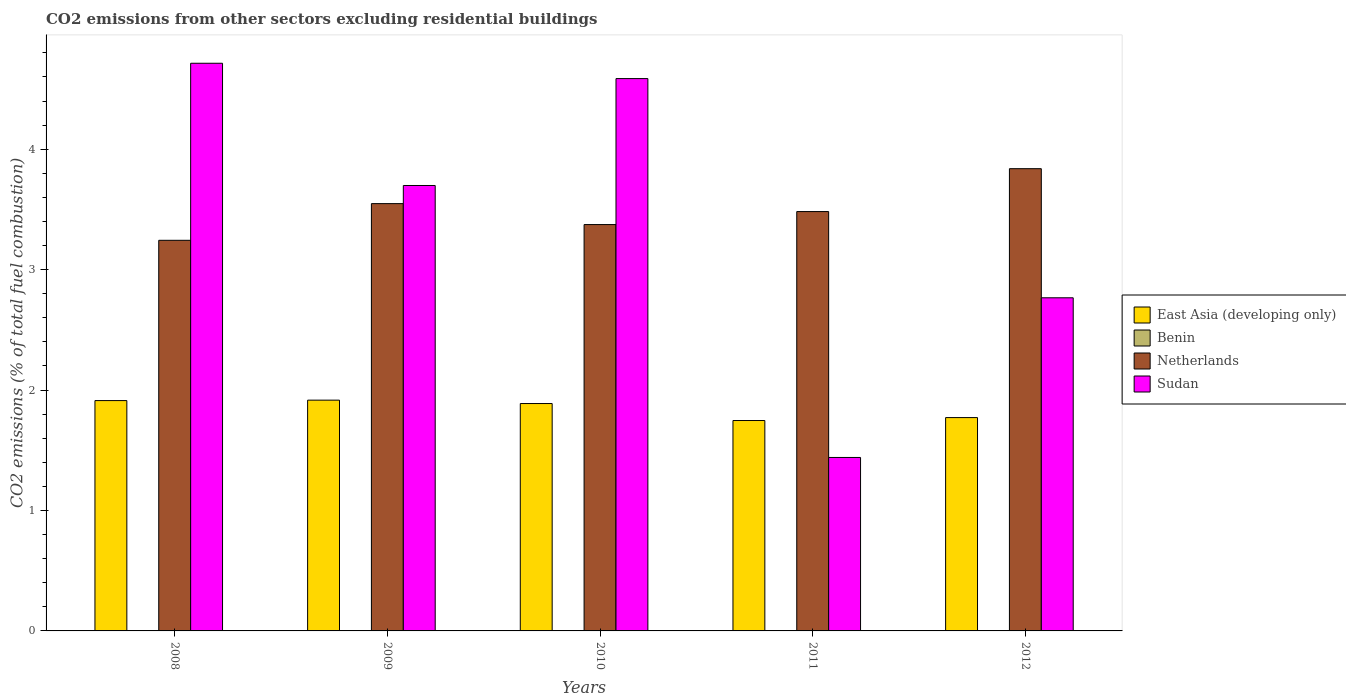How many groups of bars are there?
Offer a very short reply. 5. Are the number of bars per tick equal to the number of legend labels?
Your answer should be very brief. No. How many bars are there on the 5th tick from the left?
Your answer should be compact. 4. How many bars are there on the 4th tick from the right?
Your answer should be compact. 3. What is the total CO2 emitted in East Asia (developing only) in 2009?
Give a very brief answer. 1.92. Across all years, what is the maximum total CO2 emitted in Sudan?
Offer a terse response. 4.71. Across all years, what is the minimum total CO2 emitted in Benin?
Your answer should be very brief. 0. In which year was the total CO2 emitted in Benin maximum?
Provide a succinct answer. 2008. What is the total total CO2 emitted in Benin in the graph?
Provide a succinct answer. 7.807697859994709e-16. What is the difference between the total CO2 emitted in East Asia (developing only) in 2008 and that in 2012?
Make the answer very short. 0.14. What is the difference between the total CO2 emitted in Sudan in 2011 and the total CO2 emitted in East Asia (developing only) in 2009?
Provide a short and direct response. -0.48. What is the average total CO2 emitted in Sudan per year?
Provide a succinct answer. 3.44. In the year 2009, what is the difference between the total CO2 emitted in Sudan and total CO2 emitted in Netherlands?
Provide a short and direct response. 0.15. In how many years, is the total CO2 emitted in Netherlands greater than 1.4?
Provide a succinct answer. 5. What is the ratio of the total CO2 emitted in East Asia (developing only) in 2008 to that in 2011?
Offer a very short reply. 1.09. What is the difference between the highest and the second highest total CO2 emitted in Sudan?
Ensure brevity in your answer.  0.13. What is the difference between the highest and the lowest total CO2 emitted in Benin?
Your answer should be compact. 2.282530889443169e-16. In how many years, is the total CO2 emitted in Benin greater than the average total CO2 emitted in Benin taken over all years?
Offer a terse response. 4. Is the sum of the total CO2 emitted in Benin in 2010 and 2011 greater than the maximum total CO2 emitted in East Asia (developing only) across all years?
Offer a very short reply. No. How many bars are there?
Give a very brief answer. 19. Are all the bars in the graph horizontal?
Your answer should be very brief. No. What is the difference between two consecutive major ticks on the Y-axis?
Make the answer very short. 1. Does the graph contain grids?
Keep it short and to the point. No. How many legend labels are there?
Provide a succinct answer. 4. What is the title of the graph?
Provide a succinct answer. CO2 emissions from other sectors excluding residential buildings. What is the label or title of the Y-axis?
Keep it short and to the point. CO2 emissions (% of total fuel combustion). What is the CO2 emissions (% of total fuel combustion) in East Asia (developing only) in 2008?
Provide a short and direct response. 1.91. What is the CO2 emissions (% of total fuel combustion) in Benin in 2008?
Ensure brevity in your answer.  2.282530889443169e-16. What is the CO2 emissions (% of total fuel combustion) in Netherlands in 2008?
Ensure brevity in your answer.  3.24. What is the CO2 emissions (% of total fuel combustion) of Sudan in 2008?
Provide a short and direct response. 4.71. What is the CO2 emissions (% of total fuel combustion) in East Asia (developing only) in 2009?
Make the answer very short. 1.92. What is the CO2 emissions (% of total fuel combustion) of Benin in 2009?
Keep it short and to the point. 0. What is the CO2 emissions (% of total fuel combustion) in Netherlands in 2009?
Your answer should be compact. 3.55. What is the CO2 emissions (% of total fuel combustion) in Sudan in 2009?
Your answer should be very brief. 3.7. What is the CO2 emissions (% of total fuel combustion) in East Asia (developing only) in 2010?
Provide a succinct answer. 1.89. What is the CO2 emissions (% of total fuel combustion) of Benin in 2010?
Keep it short and to the point. 1.92747052886312e-16. What is the CO2 emissions (% of total fuel combustion) of Netherlands in 2010?
Provide a short and direct response. 3.37. What is the CO2 emissions (% of total fuel combustion) of Sudan in 2010?
Offer a very short reply. 4.59. What is the CO2 emissions (% of total fuel combustion) in East Asia (developing only) in 2011?
Offer a terse response. 1.75. What is the CO2 emissions (% of total fuel combustion) of Benin in 2011?
Provide a short and direct response. 1.84545050635831e-16. What is the CO2 emissions (% of total fuel combustion) of Netherlands in 2011?
Offer a terse response. 3.48. What is the CO2 emissions (% of total fuel combustion) in Sudan in 2011?
Give a very brief answer. 1.44. What is the CO2 emissions (% of total fuel combustion) of East Asia (developing only) in 2012?
Your response must be concise. 1.77. What is the CO2 emissions (% of total fuel combustion) of Benin in 2012?
Give a very brief answer. 1.75224593533011e-16. What is the CO2 emissions (% of total fuel combustion) of Netherlands in 2012?
Provide a succinct answer. 3.84. What is the CO2 emissions (% of total fuel combustion) of Sudan in 2012?
Make the answer very short. 2.77. Across all years, what is the maximum CO2 emissions (% of total fuel combustion) in East Asia (developing only)?
Keep it short and to the point. 1.92. Across all years, what is the maximum CO2 emissions (% of total fuel combustion) of Benin?
Your response must be concise. 2.282530889443169e-16. Across all years, what is the maximum CO2 emissions (% of total fuel combustion) in Netherlands?
Ensure brevity in your answer.  3.84. Across all years, what is the maximum CO2 emissions (% of total fuel combustion) of Sudan?
Your answer should be very brief. 4.71. Across all years, what is the minimum CO2 emissions (% of total fuel combustion) in East Asia (developing only)?
Provide a succinct answer. 1.75. Across all years, what is the minimum CO2 emissions (% of total fuel combustion) in Benin?
Offer a very short reply. 0. Across all years, what is the minimum CO2 emissions (% of total fuel combustion) of Netherlands?
Offer a terse response. 3.24. Across all years, what is the minimum CO2 emissions (% of total fuel combustion) of Sudan?
Keep it short and to the point. 1.44. What is the total CO2 emissions (% of total fuel combustion) in East Asia (developing only) in the graph?
Your answer should be compact. 9.24. What is the total CO2 emissions (% of total fuel combustion) of Benin in the graph?
Provide a succinct answer. 0. What is the total CO2 emissions (% of total fuel combustion) of Netherlands in the graph?
Ensure brevity in your answer.  17.49. What is the total CO2 emissions (% of total fuel combustion) in Sudan in the graph?
Keep it short and to the point. 17.21. What is the difference between the CO2 emissions (% of total fuel combustion) of East Asia (developing only) in 2008 and that in 2009?
Ensure brevity in your answer.  -0. What is the difference between the CO2 emissions (% of total fuel combustion) in Netherlands in 2008 and that in 2009?
Give a very brief answer. -0.3. What is the difference between the CO2 emissions (% of total fuel combustion) in Sudan in 2008 and that in 2009?
Offer a terse response. 1.01. What is the difference between the CO2 emissions (% of total fuel combustion) in East Asia (developing only) in 2008 and that in 2010?
Ensure brevity in your answer.  0.02. What is the difference between the CO2 emissions (% of total fuel combustion) of Benin in 2008 and that in 2010?
Offer a terse response. 0. What is the difference between the CO2 emissions (% of total fuel combustion) in Netherlands in 2008 and that in 2010?
Offer a terse response. -0.13. What is the difference between the CO2 emissions (% of total fuel combustion) of Sudan in 2008 and that in 2010?
Ensure brevity in your answer.  0.13. What is the difference between the CO2 emissions (% of total fuel combustion) in East Asia (developing only) in 2008 and that in 2011?
Your answer should be very brief. 0.17. What is the difference between the CO2 emissions (% of total fuel combustion) of Benin in 2008 and that in 2011?
Ensure brevity in your answer.  0. What is the difference between the CO2 emissions (% of total fuel combustion) in Netherlands in 2008 and that in 2011?
Your answer should be very brief. -0.24. What is the difference between the CO2 emissions (% of total fuel combustion) in Sudan in 2008 and that in 2011?
Keep it short and to the point. 3.27. What is the difference between the CO2 emissions (% of total fuel combustion) in East Asia (developing only) in 2008 and that in 2012?
Make the answer very short. 0.14. What is the difference between the CO2 emissions (% of total fuel combustion) of Benin in 2008 and that in 2012?
Offer a terse response. 0. What is the difference between the CO2 emissions (% of total fuel combustion) of Netherlands in 2008 and that in 2012?
Offer a terse response. -0.59. What is the difference between the CO2 emissions (% of total fuel combustion) of Sudan in 2008 and that in 2012?
Keep it short and to the point. 1.95. What is the difference between the CO2 emissions (% of total fuel combustion) in East Asia (developing only) in 2009 and that in 2010?
Your answer should be compact. 0.03. What is the difference between the CO2 emissions (% of total fuel combustion) of Netherlands in 2009 and that in 2010?
Provide a succinct answer. 0.17. What is the difference between the CO2 emissions (% of total fuel combustion) in Sudan in 2009 and that in 2010?
Make the answer very short. -0.89. What is the difference between the CO2 emissions (% of total fuel combustion) in East Asia (developing only) in 2009 and that in 2011?
Ensure brevity in your answer.  0.17. What is the difference between the CO2 emissions (% of total fuel combustion) of Netherlands in 2009 and that in 2011?
Offer a terse response. 0.07. What is the difference between the CO2 emissions (% of total fuel combustion) of Sudan in 2009 and that in 2011?
Your answer should be very brief. 2.26. What is the difference between the CO2 emissions (% of total fuel combustion) in East Asia (developing only) in 2009 and that in 2012?
Your response must be concise. 0.14. What is the difference between the CO2 emissions (% of total fuel combustion) of Netherlands in 2009 and that in 2012?
Your answer should be compact. -0.29. What is the difference between the CO2 emissions (% of total fuel combustion) of Sudan in 2009 and that in 2012?
Offer a very short reply. 0.93. What is the difference between the CO2 emissions (% of total fuel combustion) of East Asia (developing only) in 2010 and that in 2011?
Provide a succinct answer. 0.14. What is the difference between the CO2 emissions (% of total fuel combustion) in Netherlands in 2010 and that in 2011?
Your answer should be very brief. -0.11. What is the difference between the CO2 emissions (% of total fuel combustion) in Sudan in 2010 and that in 2011?
Provide a succinct answer. 3.15. What is the difference between the CO2 emissions (% of total fuel combustion) of East Asia (developing only) in 2010 and that in 2012?
Make the answer very short. 0.12. What is the difference between the CO2 emissions (% of total fuel combustion) of Netherlands in 2010 and that in 2012?
Ensure brevity in your answer.  -0.46. What is the difference between the CO2 emissions (% of total fuel combustion) in Sudan in 2010 and that in 2012?
Your answer should be very brief. 1.82. What is the difference between the CO2 emissions (% of total fuel combustion) of East Asia (developing only) in 2011 and that in 2012?
Your answer should be compact. -0.02. What is the difference between the CO2 emissions (% of total fuel combustion) in Netherlands in 2011 and that in 2012?
Your answer should be very brief. -0.36. What is the difference between the CO2 emissions (% of total fuel combustion) in Sudan in 2011 and that in 2012?
Your response must be concise. -1.33. What is the difference between the CO2 emissions (% of total fuel combustion) in East Asia (developing only) in 2008 and the CO2 emissions (% of total fuel combustion) in Netherlands in 2009?
Give a very brief answer. -1.64. What is the difference between the CO2 emissions (% of total fuel combustion) in East Asia (developing only) in 2008 and the CO2 emissions (% of total fuel combustion) in Sudan in 2009?
Provide a succinct answer. -1.79. What is the difference between the CO2 emissions (% of total fuel combustion) in Benin in 2008 and the CO2 emissions (% of total fuel combustion) in Netherlands in 2009?
Give a very brief answer. -3.55. What is the difference between the CO2 emissions (% of total fuel combustion) in Benin in 2008 and the CO2 emissions (% of total fuel combustion) in Sudan in 2009?
Your response must be concise. -3.7. What is the difference between the CO2 emissions (% of total fuel combustion) in Netherlands in 2008 and the CO2 emissions (% of total fuel combustion) in Sudan in 2009?
Provide a succinct answer. -0.46. What is the difference between the CO2 emissions (% of total fuel combustion) of East Asia (developing only) in 2008 and the CO2 emissions (% of total fuel combustion) of Benin in 2010?
Offer a terse response. 1.91. What is the difference between the CO2 emissions (% of total fuel combustion) of East Asia (developing only) in 2008 and the CO2 emissions (% of total fuel combustion) of Netherlands in 2010?
Ensure brevity in your answer.  -1.46. What is the difference between the CO2 emissions (% of total fuel combustion) of East Asia (developing only) in 2008 and the CO2 emissions (% of total fuel combustion) of Sudan in 2010?
Your answer should be very brief. -2.67. What is the difference between the CO2 emissions (% of total fuel combustion) in Benin in 2008 and the CO2 emissions (% of total fuel combustion) in Netherlands in 2010?
Ensure brevity in your answer.  -3.37. What is the difference between the CO2 emissions (% of total fuel combustion) of Benin in 2008 and the CO2 emissions (% of total fuel combustion) of Sudan in 2010?
Your response must be concise. -4.59. What is the difference between the CO2 emissions (% of total fuel combustion) of Netherlands in 2008 and the CO2 emissions (% of total fuel combustion) of Sudan in 2010?
Offer a very short reply. -1.34. What is the difference between the CO2 emissions (% of total fuel combustion) in East Asia (developing only) in 2008 and the CO2 emissions (% of total fuel combustion) in Benin in 2011?
Your answer should be very brief. 1.91. What is the difference between the CO2 emissions (% of total fuel combustion) in East Asia (developing only) in 2008 and the CO2 emissions (% of total fuel combustion) in Netherlands in 2011?
Ensure brevity in your answer.  -1.57. What is the difference between the CO2 emissions (% of total fuel combustion) in East Asia (developing only) in 2008 and the CO2 emissions (% of total fuel combustion) in Sudan in 2011?
Provide a succinct answer. 0.47. What is the difference between the CO2 emissions (% of total fuel combustion) in Benin in 2008 and the CO2 emissions (% of total fuel combustion) in Netherlands in 2011?
Provide a short and direct response. -3.48. What is the difference between the CO2 emissions (% of total fuel combustion) of Benin in 2008 and the CO2 emissions (% of total fuel combustion) of Sudan in 2011?
Make the answer very short. -1.44. What is the difference between the CO2 emissions (% of total fuel combustion) of Netherlands in 2008 and the CO2 emissions (% of total fuel combustion) of Sudan in 2011?
Offer a very short reply. 1.8. What is the difference between the CO2 emissions (% of total fuel combustion) in East Asia (developing only) in 2008 and the CO2 emissions (% of total fuel combustion) in Benin in 2012?
Ensure brevity in your answer.  1.91. What is the difference between the CO2 emissions (% of total fuel combustion) in East Asia (developing only) in 2008 and the CO2 emissions (% of total fuel combustion) in Netherlands in 2012?
Ensure brevity in your answer.  -1.93. What is the difference between the CO2 emissions (% of total fuel combustion) of East Asia (developing only) in 2008 and the CO2 emissions (% of total fuel combustion) of Sudan in 2012?
Provide a short and direct response. -0.85. What is the difference between the CO2 emissions (% of total fuel combustion) of Benin in 2008 and the CO2 emissions (% of total fuel combustion) of Netherlands in 2012?
Your answer should be very brief. -3.84. What is the difference between the CO2 emissions (% of total fuel combustion) in Benin in 2008 and the CO2 emissions (% of total fuel combustion) in Sudan in 2012?
Offer a very short reply. -2.77. What is the difference between the CO2 emissions (% of total fuel combustion) of Netherlands in 2008 and the CO2 emissions (% of total fuel combustion) of Sudan in 2012?
Your answer should be compact. 0.48. What is the difference between the CO2 emissions (% of total fuel combustion) in East Asia (developing only) in 2009 and the CO2 emissions (% of total fuel combustion) in Benin in 2010?
Offer a very short reply. 1.92. What is the difference between the CO2 emissions (% of total fuel combustion) in East Asia (developing only) in 2009 and the CO2 emissions (% of total fuel combustion) in Netherlands in 2010?
Ensure brevity in your answer.  -1.46. What is the difference between the CO2 emissions (% of total fuel combustion) of East Asia (developing only) in 2009 and the CO2 emissions (% of total fuel combustion) of Sudan in 2010?
Ensure brevity in your answer.  -2.67. What is the difference between the CO2 emissions (% of total fuel combustion) in Netherlands in 2009 and the CO2 emissions (% of total fuel combustion) in Sudan in 2010?
Your answer should be very brief. -1.04. What is the difference between the CO2 emissions (% of total fuel combustion) of East Asia (developing only) in 2009 and the CO2 emissions (% of total fuel combustion) of Benin in 2011?
Keep it short and to the point. 1.92. What is the difference between the CO2 emissions (% of total fuel combustion) in East Asia (developing only) in 2009 and the CO2 emissions (% of total fuel combustion) in Netherlands in 2011?
Provide a succinct answer. -1.57. What is the difference between the CO2 emissions (% of total fuel combustion) of East Asia (developing only) in 2009 and the CO2 emissions (% of total fuel combustion) of Sudan in 2011?
Offer a terse response. 0.48. What is the difference between the CO2 emissions (% of total fuel combustion) of Netherlands in 2009 and the CO2 emissions (% of total fuel combustion) of Sudan in 2011?
Provide a succinct answer. 2.11. What is the difference between the CO2 emissions (% of total fuel combustion) of East Asia (developing only) in 2009 and the CO2 emissions (% of total fuel combustion) of Benin in 2012?
Make the answer very short. 1.92. What is the difference between the CO2 emissions (% of total fuel combustion) in East Asia (developing only) in 2009 and the CO2 emissions (% of total fuel combustion) in Netherlands in 2012?
Your answer should be very brief. -1.92. What is the difference between the CO2 emissions (% of total fuel combustion) in East Asia (developing only) in 2009 and the CO2 emissions (% of total fuel combustion) in Sudan in 2012?
Your answer should be very brief. -0.85. What is the difference between the CO2 emissions (% of total fuel combustion) of Netherlands in 2009 and the CO2 emissions (% of total fuel combustion) of Sudan in 2012?
Keep it short and to the point. 0.78. What is the difference between the CO2 emissions (% of total fuel combustion) in East Asia (developing only) in 2010 and the CO2 emissions (% of total fuel combustion) in Benin in 2011?
Your answer should be compact. 1.89. What is the difference between the CO2 emissions (% of total fuel combustion) in East Asia (developing only) in 2010 and the CO2 emissions (% of total fuel combustion) in Netherlands in 2011?
Your answer should be very brief. -1.59. What is the difference between the CO2 emissions (% of total fuel combustion) in East Asia (developing only) in 2010 and the CO2 emissions (% of total fuel combustion) in Sudan in 2011?
Your answer should be compact. 0.45. What is the difference between the CO2 emissions (% of total fuel combustion) in Benin in 2010 and the CO2 emissions (% of total fuel combustion) in Netherlands in 2011?
Your answer should be very brief. -3.48. What is the difference between the CO2 emissions (% of total fuel combustion) of Benin in 2010 and the CO2 emissions (% of total fuel combustion) of Sudan in 2011?
Make the answer very short. -1.44. What is the difference between the CO2 emissions (% of total fuel combustion) of Netherlands in 2010 and the CO2 emissions (% of total fuel combustion) of Sudan in 2011?
Provide a short and direct response. 1.93. What is the difference between the CO2 emissions (% of total fuel combustion) in East Asia (developing only) in 2010 and the CO2 emissions (% of total fuel combustion) in Benin in 2012?
Offer a terse response. 1.89. What is the difference between the CO2 emissions (% of total fuel combustion) of East Asia (developing only) in 2010 and the CO2 emissions (% of total fuel combustion) of Netherlands in 2012?
Your answer should be compact. -1.95. What is the difference between the CO2 emissions (% of total fuel combustion) of East Asia (developing only) in 2010 and the CO2 emissions (% of total fuel combustion) of Sudan in 2012?
Make the answer very short. -0.88. What is the difference between the CO2 emissions (% of total fuel combustion) in Benin in 2010 and the CO2 emissions (% of total fuel combustion) in Netherlands in 2012?
Offer a very short reply. -3.84. What is the difference between the CO2 emissions (% of total fuel combustion) in Benin in 2010 and the CO2 emissions (% of total fuel combustion) in Sudan in 2012?
Offer a very short reply. -2.77. What is the difference between the CO2 emissions (% of total fuel combustion) of Netherlands in 2010 and the CO2 emissions (% of total fuel combustion) of Sudan in 2012?
Provide a succinct answer. 0.61. What is the difference between the CO2 emissions (% of total fuel combustion) of East Asia (developing only) in 2011 and the CO2 emissions (% of total fuel combustion) of Benin in 2012?
Provide a succinct answer. 1.75. What is the difference between the CO2 emissions (% of total fuel combustion) in East Asia (developing only) in 2011 and the CO2 emissions (% of total fuel combustion) in Netherlands in 2012?
Ensure brevity in your answer.  -2.09. What is the difference between the CO2 emissions (% of total fuel combustion) in East Asia (developing only) in 2011 and the CO2 emissions (% of total fuel combustion) in Sudan in 2012?
Your answer should be very brief. -1.02. What is the difference between the CO2 emissions (% of total fuel combustion) in Benin in 2011 and the CO2 emissions (% of total fuel combustion) in Netherlands in 2012?
Give a very brief answer. -3.84. What is the difference between the CO2 emissions (% of total fuel combustion) of Benin in 2011 and the CO2 emissions (% of total fuel combustion) of Sudan in 2012?
Provide a succinct answer. -2.77. What is the difference between the CO2 emissions (% of total fuel combustion) in Netherlands in 2011 and the CO2 emissions (% of total fuel combustion) in Sudan in 2012?
Your answer should be compact. 0.72. What is the average CO2 emissions (% of total fuel combustion) in East Asia (developing only) per year?
Give a very brief answer. 1.85. What is the average CO2 emissions (% of total fuel combustion) in Benin per year?
Make the answer very short. 0. What is the average CO2 emissions (% of total fuel combustion) of Netherlands per year?
Offer a terse response. 3.5. What is the average CO2 emissions (% of total fuel combustion) in Sudan per year?
Your response must be concise. 3.44. In the year 2008, what is the difference between the CO2 emissions (% of total fuel combustion) of East Asia (developing only) and CO2 emissions (% of total fuel combustion) of Benin?
Provide a short and direct response. 1.91. In the year 2008, what is the difference between the CO2 emissions (% of total fuel combustion) in East Asia (developing only) and CO2 emissions (% of total fuel combustion) in Netherlands?
Keep it short and to the point. -1.33. In the year 2008, what is the difference between the CO2 emissions (% of total fuel combustion) of East Asia (developing only) and CO2 emissions (% of total fuel combustion) of Sudan?
Your answer should be very brief. -2.8. In the year 2008, what is the difference between the CO2 emissions (% of total fuel combustion) of Benin and CO2 emissions (% of total fuel combustion) of Netherlands?
Offer a terse response. -3.24. In the year 2008, what is the difference between the CO2 emissions (% of total fuel combustion) of Benin and CO2 emissions (% of total fuel combustion) of Sudan?
Provide a succinct answer. -4.71. In the year 2008, what is the difference between the CO2 emissions (% of total fuel combustion) in Netherlands and CO2 emissions (% of total fuel combustion) in Sudan?
Provide a short and direct response. -1.47. In the year 2009, what is the difference between the CO2 emissions (% of total fuel combustion) of East Asia (developing only) and CO2 emissions (% of total fuel combustion) of Netherlands?
Provide a succinct answer. -1.63. In the year 2009, what is the difference between the CO2 emissions (% of total fuel combustion) in East Asia (developing only) and CO2 emissions (% of total fuel combustion) in Sudan?
Give a very brief answer. -1.78. In the year 2009, what is the difference between the CO2 emissions (% of total fuel combustion) of Netherlands and CO2 emissions (% of total fuel combustion) of Sudan?
Provide a short and direct response. -0.15. In the year 2010, what is the difference between the CO2 emissions (% of total fuel combustion) of East Asia (developing only) and CO2 emissions (% of total fuel combustion) of Benin?
Offer a terse response. 1.89. In the year 2010, what is the difference between the CO2 emissions (% of total fuel combustion) in East Asia (developing only) and CO2 emissions (% of total fuel combustion) in Netherlands?
Your response must be concise. -1.49. In the year 2010, what is the difference between the CO2 emissions (% of total fuel combustion) of East Asia (developing only) and CO2 emissions (% of total fuel combustion) of Sudan?
Your response must be concise. -2.7. In the year 2010, what is the difference between the CO2 emissions (% of total fuel combustion) in Benin and CO2 emissions (% of total fuel combustion) in Netherlands?
Offer a very short reply. -3.37. In the year 2010, what is the difference between the CO2 emissions (% of total fuel combustion) in Benin and CO2 emissions (% of total fuel combustion) in Sudan?
Provide a short and direct response. -4.59. In the year 2010, what is the difference between the CO2 emissions (% of total fuel combustion) of Netherlands and CO2 emissions (% of total fuel combustion) of Sudan?
Your answer should be compact. -1.21. In the year 2011, what is the difference between the CO2 emissions (% of total fuel combustion) of East Asia (developing only) and CO2 emissions (% of total fuel combustion) of Benin?
Offer a very short reply. 1.75. In the year 2011, what is the difference between the CO2 emissions (% of total fuel combustion) of East Asia (developing only) and CO2 emissions (% of total fuel combustion) of Netherlands?
Offer a terse response. -1.74. In the year 2011, what is the difference between the CO2 emissions (% of total fuel combustion) of East Asia (developing only) and CO2 emissions (% of total fuel combustion) of Sudan?
Make the answer very short. 0.31. In the year 2011, what is the difference between the CO2 emissions (% of total fuel combustion) of Benin and CO2 emissions (% of total fuel combustion) of Netherlands?
Offer a terse response. -3.48. In the year 2011, what is the difference between the CO2 emissions (% of total fuel combustion) in Benin and CO2 emissions (% of total fuel combustion) in Sudan?
Provide a short and direct response. -1.44. In the year 2011, what is the difference between the CO2 emissions (% of total fuel combustion) in Netherlands and CO2 emissions (% of total fuel combustion) in Sudan?
Make the answer very short. 2.04. In the year 2012, what is the difference between the CO2 emissions (% of total fuel combustion) of East Asia (developing only) and CO2 emissions (% of total fuel combustion) of Benin?
Your response must be concise. 1.77. In the year 2012, what is the difference between the CO2 emissions (% of total fuel combustion) in East Asia (developing only) and CO2 emissions (% of total fuel combustion) in Netherlands?
Your answer should be very brief. -2.07. In the year 2012, what is the difference between the CO2 emissions (% of total fuel combustion) in East Asia (developing only) and CO2 emissions (% of total fuel combustion) in Sudan?
Offer a terse response. -0.99. In the year 2012, what is the difference between the CO2 emissions (% of total fuel combustion) of Benin and CO2 emissions (% of total fuel combustion) of Netherlands?
Provide a short and direct response. -3.84. In the year 2012, what is the difference between the CO2 emissions (% of total fuel combustion) in Benin and CO2 emissions (% of total fuel combustion) in Sudan?
Keep it short and to the point. -2.77. In the year 2012, what is the difference between the CO2 emissions (% of total fuel combustion) of Netherlands and CO2 emissions (% of total fuel combustion) of Sudan?
Give a very brief answer. 1.07. What is the ratio of the CO2 emissions (% of total fuel combustion) in Netherlands in 2008 to that in 2009?
Offer a very short reply. 0.91. What is the ratio of the CO2 emissions (% of total fuel combustion) in Sudan in 2008 to that in 2009?
Offer a very short reply. 1.27. What is the ratio of the CO2 emissions (% of total fuel combustion) of East Asia (developing only) in 2008 to that in 2010?
Your response must be concise. 1.01. What is the ratio of the CO2 emissions (% of total fuel combustion) in Benin in 2008 to that in 2010?
Give a very brief answer. 1.18. What is the ratio of the CO2 emissions (% of total fuel combustion) of Netherlands in 2008 to that in 2010?
Your answer should be compact. 0.96. What is the ratio of the CO2 emissions (% of total fuel combustion) of Sudan in 2008 to that in 2010?
Your answer should be compact. 1.03. What is the ratio of the CO2 emissions (% of total fuel combustion) in East Asia (developing only) in 2008 to that in 2011?
Your response must be concise. 1.09. What is the ratio of the CO2 emissions (% of total fuel combustion) of Benin in 2008 to that in 2011?
Offer a very short reply. 1.24. What is the ratio of the CO2 emissions (% of total fuel combustion) in Netherlands in 2008 to that in 2011?
Provide a short and direct response. 0.93. What is the ratio of the CO2 emissions (% of total fuel combustion) in Sudan in 2008 to that in 2011?
Make the answer very short. 3.27. What is the ratio of the CO2 emissions (% of total fuel combustion) in East Asia (developing only) in 2008 to that in 2012?
Provide a short and direct response. 1.08. What is the ratio of the CO2 emissions (% of total fuel combustion) of Benin in 2008 to that in 2012?
Your answer should be compact. 1.3. What is the ratio of the CO2 emissions (% of total fuel combustion) in Netherlands in 2008 to that in 2012?
Give a very brief answer. 0.84. What is the ratio of the CO2 emissions (% of total fuel combustion) in Sudan in 2008 to that in 2012?
Offer a terse response. 1.7. What is the ratio of the CO2 emissions (% of total fuel combustion) in East Asia (developing only) in 2009 to that in 2010?
Provide a succinct answer. 1.01. What is the ratio of the CO2 emissions (% of total fuel combustion) of Netherlands in 2009 to that in 2010?
Give a very brief answer. 1.05. What is the ratio of the CO2 emissions (% of total fuel combustion) in Sudan in 2009 to that in 2010?
Provide a succinct answer. 0.81. What is the ratio of the CO2 emissions (% of total fuel combustion) in East Asia (developing only) in 2009 to that in 2011?
Offer a terse response. 1.1. What is the ratio of the CO2 emissions (% of total fuel combustion) in Netherlands in 2009 to that in 2011?
Your answer should be compact. 1.02. What is the ratio of the CO2 emissions (% of total fuel combustion) of Sudan in 2009 to that in 2011?
Make the answer very short. 2.57. What is the ratio of the CO2 emissions (% of total fuel combustion) of East Asia (developing only) in 2009 to that in 2012?
Your response must be concise. 1.08. What is the ratio of the CO2 emissions (% of total fuel combustion) of Netherlands in 2009 to that in 2012?
Provide a succinct answer. 0.92. What is the ratio of the CO2 emissions (% of total fuel combustion) of Sudan in 2009 to that in 2012?
Ensure brevity in your answer.  1.34. What is the ratio of the CO2 emissions (% of total fuel combustion) of East Asia (developing only) in 2010 to that in 2011?
Ensure brevity in your answer.  1.08. What is the ratio of the CO2 emissions (% of total fuel combustion) in Benin in 2010 to that in 2011?
Your response must be concise. 1.04. What is the ratio of the CO2 emissions (% of total fuel combustion) in Netherlands in 2010 to that in 2011?
Your answer should be compact. 0.97. What is the ratio of the CO2 emissions (% of total fuel combustion) in Sudan in 2010 to that in 2011?
Offer a terse response. 3.18. What is the ratio of the CO2 emissions (% of total fuel combustion) in East Asia (developing only) in 2010 to that in 2012?
Offer a very short reply. 1.07. What is the ratio of the CO2 emissions (% of total fuel combustion) of Benin in 2010 to that in 2012?
Your answer should be compact. 1.1. What is the ratio of the CO2 emissions (% of total fuel combustion) in Netherlands in 2010 to that in 2012?
Give a very brief answer. 0.88. What is the ratio of the CO2 emissions (% of total fuel combustion) in Sudan in 2010 to that in 2012?
Your answer should be very brief. 1.66. What is the ratio of the CO2 emissions (% of total fuel combustion) of East Asia (developing only) in 2011 to that in 2012?
Your response must be concise. 0.99. What is the ratio of the CO2 emissions (% of total fuel combustion) of Benin in 2011 to that in 2012?
Offer a terse response. 1.05. What is the ratio of the CO2 emissions (% of total fuel combustion) in Netherlands in 2011 to that in 2012?
Offer a terse response. 0.91. What is the ratio of the CO2 emissions (% of total fuel combustion) in Sudan in 2011 to that in 2012?
Provide a succinct answer. 0.52. What is the difference between the highest and the second highest CO2 emissions (% of total fuel combustion) of East Asia (developing only)?
Your answer should be very brief. 0. What is the difference between the highest and the second highest CO2 emissions (% of total fuel combustion) in Netherlands?
Your answer should be compact. 0.29. What is the difference between the highest and the second highest CO2 emissions (% of total fuel combustion) of Sudan?
Ensure brevity in your answer.  0.13. What is the difference between the highest and the lowest CO2 emissions (% of total fuel combustion) of East Asia (developing only)?
Keep it short and to the point. 0.17. What is the difference between the highest and the lowest CO2 emissions (% of total fuel combustion) in Netherlands?
Your answer should be very brief. 0.59. What is the difference between the highest and the lowest CO2 emissions (% of total fuel combustion) of Sudan?
Provide a succinct answer. 3.27. 